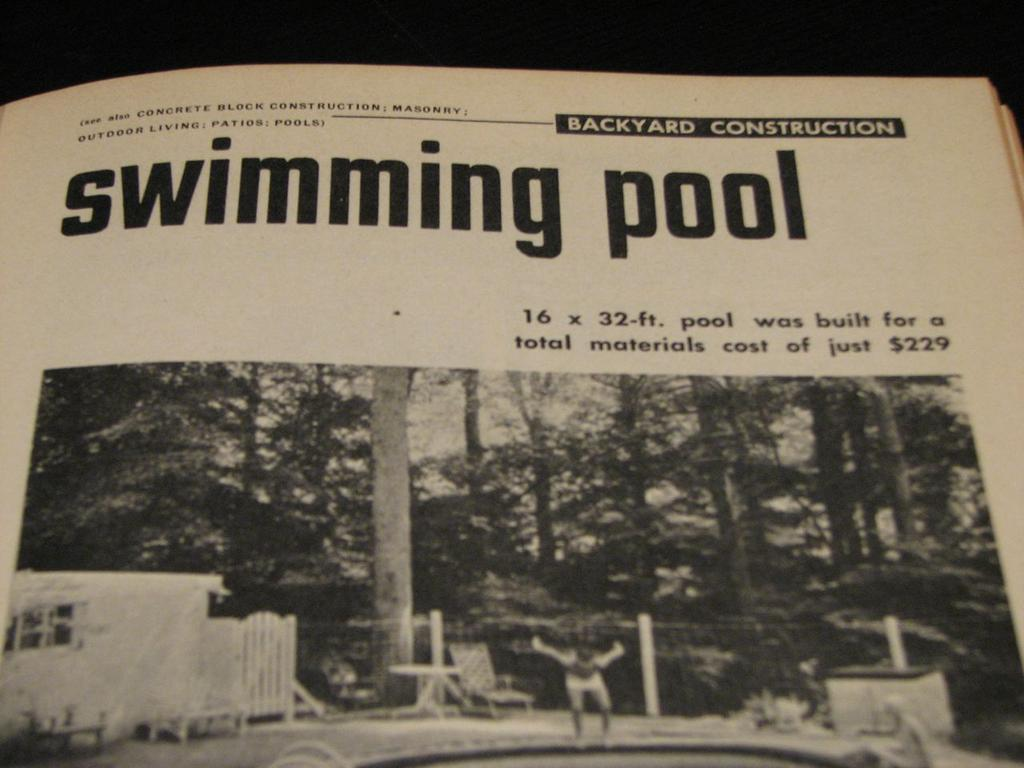What type of content is present on the pages of the book in the image? The pages of the book contain a photo, words, and numbers. Can you describe the photo on the pages of the book? Unfortunately, the specific details of the photo cannot be determined from the image. What is the background of the image like? The background of the image is dark. What type of suit is the person wearing in the image? There is no person present in the image, and therefore no suit can be observed. How many toes are visible in the image? There are no toes visible in the image, as it contains pages of a book with a photo, words, and numbers. 